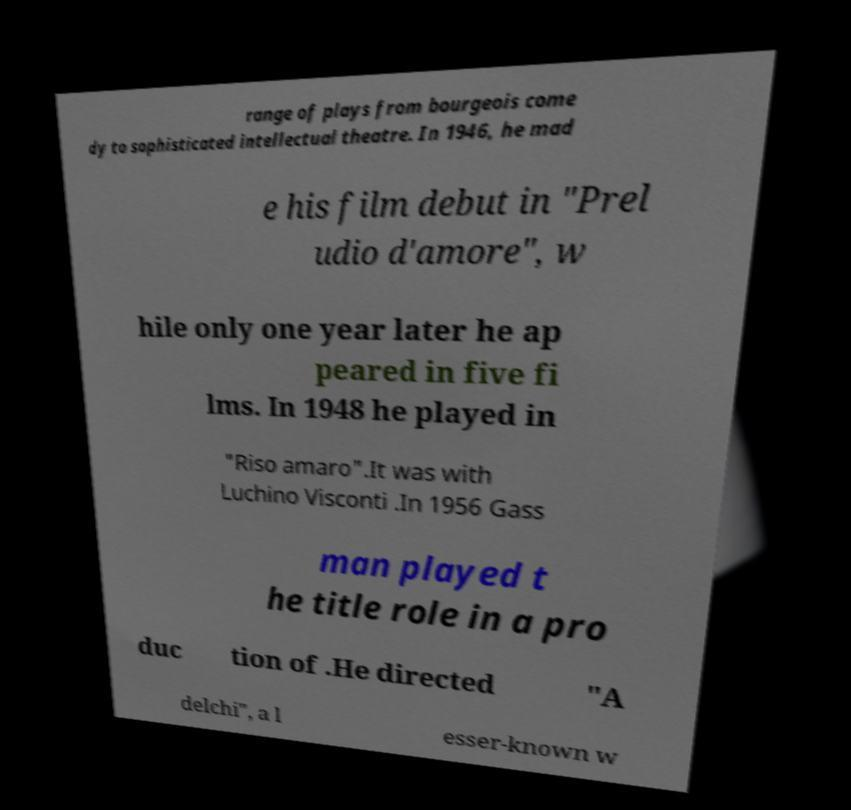What messages or text are displayed in this image? I need them in a readable, typed format. range of plays from bourgeois come dy to sophisticated intellectual theatre. In 1946, he mad e his film debut in "Prel udio d'amore", w hile only one year later he ap peared in five fi lms. In 1948 he played in "Riso amaro".It was with Luchino Visconti .In 1956 Gass man played t he title role in a pro duc tion of .He directed "A delchi", a l esser-known w 